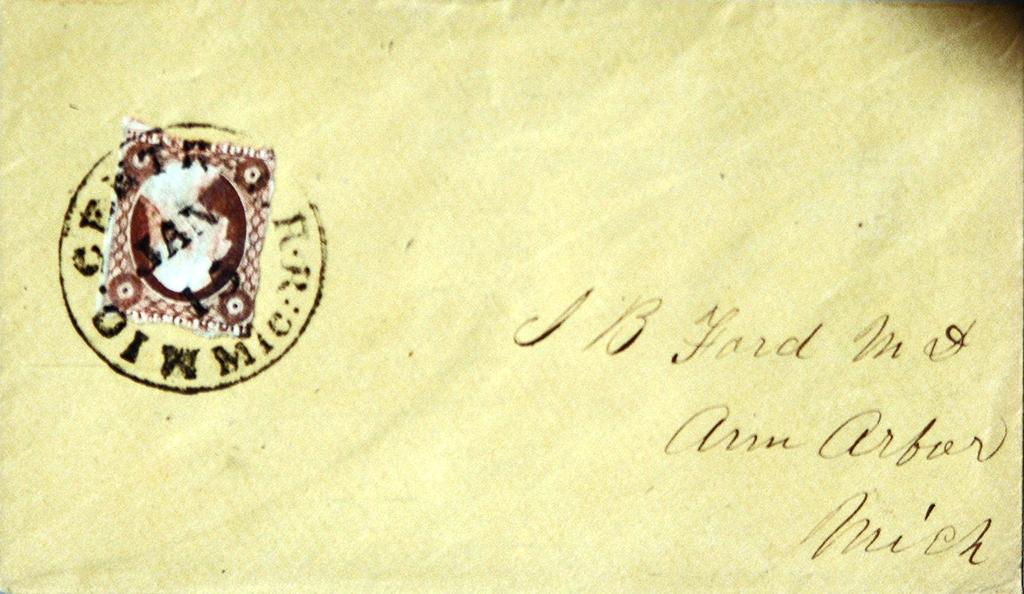What city in michigan is shown?
Keep it short and to the point. Ann arbor. Isthis a letter?
Provide a succinct answer. Yes. 